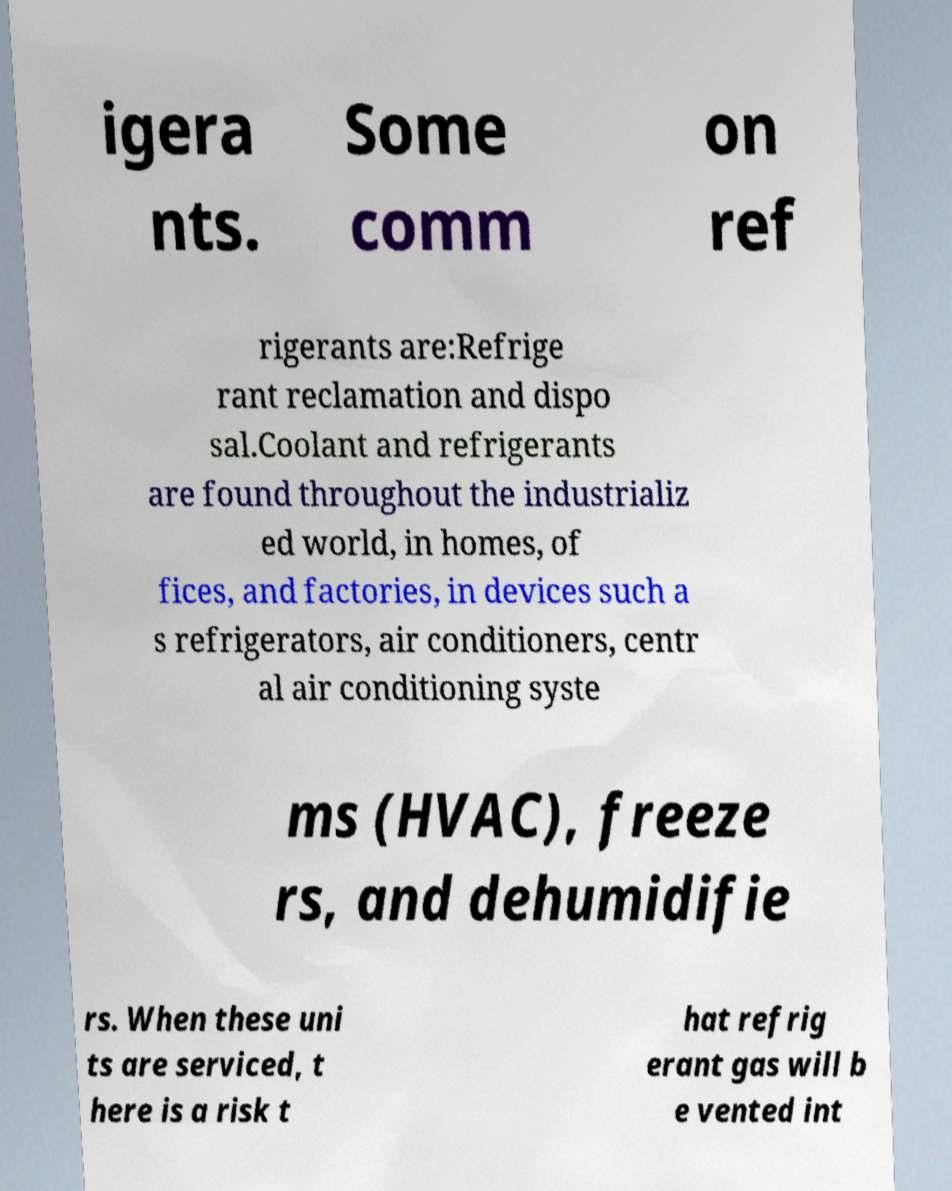Can you read and provide the text displayed in the image?This photo seems to have some interesting text. Can you extract and type it out for me? igera nts. Some comm on ref rigerants are:Refrige rant reclamation and dispo sal.Coolant and refrigerants are found throughout the industrializ ed world, in homes, of fices, and factories, in devices such a s refrigerators, air conditioners, centr al air conditioning syste ms (HVAC), freeze rs, and dehumidifie rs. When these uni ts are serviced, t here is a risk t hat refrig erant gas will b e vented int 